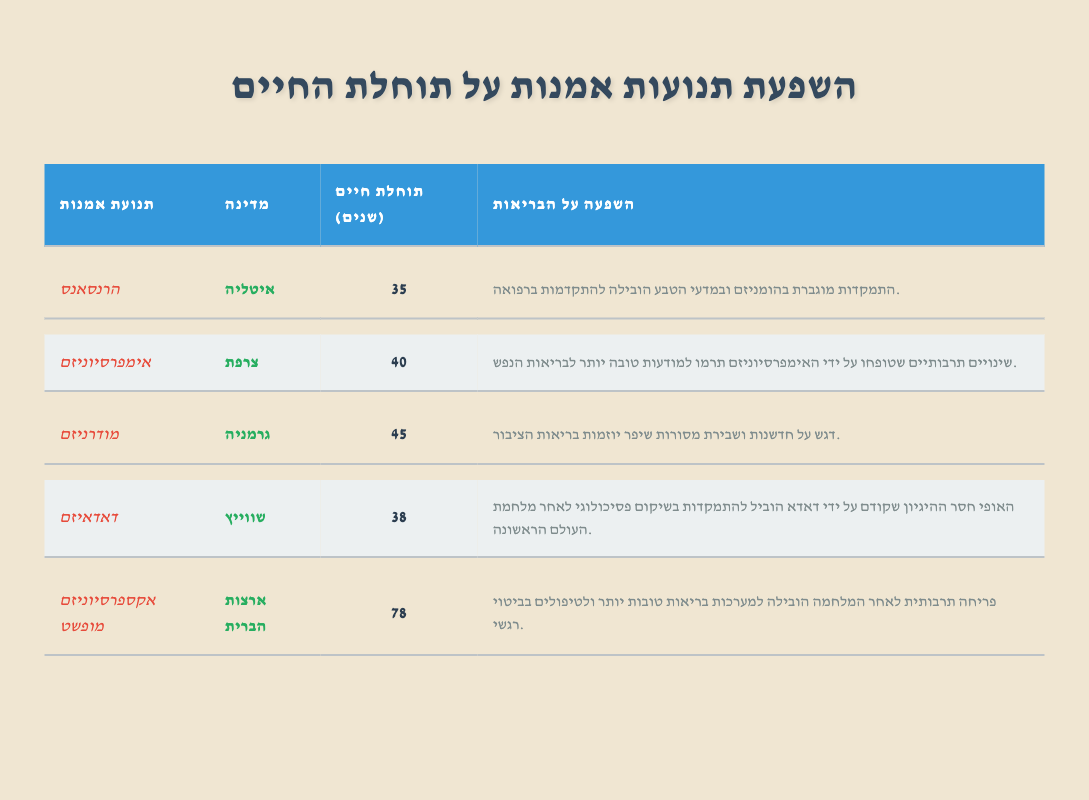What is the life expectancy in Italy? The life expectancy data for Italy, under the Renaissance art movement, is clearly stated in the table as 35 years.
Answer: 35 What country had the highest life expectancy among those listed? The country with the highest life expectancy is the United States, where the life expectancy is 78 years according to the Abstract Expressionism row.
Answer: United States What is the average life expectancy of the countries listed? To find the average life expectancy, we sum the life expectancies: 35 + 40 + 45 + 38 + 78 = 236. Then, we divide by the total number of countries listed, which is 5. Thus, the average is 236/5 = 47.2.
Answer: 47.2 Did Impressionism contribute to better mental health awareness? Yes, the influence of Impressionism on health is noted in the table, indicating it contributed to better mental health awareness.
Answer: Yes Which art movement had a potential influence on psychological rehabilitation after WWI? According to the table, Dadaism is the art movement that promoted a focus on psychological rehabilitation following WWI.
Answer: Dadaism How does the life expectancy of Abstract Expressionism compare to that of Dadaism? The life expectancy for Abstract Expressionism in the United States is 78 years, while for Dadaism in Switzerland, it's 38 years. The difference is calculated as 78 - 38 = 40 years. Thus, Abstract Expressionism has a greater life expectancy by 40 years.
Answer: 40 years Is the influence of Modernism related to advancements in public health initiatives? Yes, the table indicates that Modernism's emphasis on innovation and breaking traditions enhanced public health initiatives.
Answer: Yes What was the life expectancy for the art movement associated with Italy? The table shows that the life expectancy for the Renaissance art movement associated with Italy is 35 years.
Answer: 35 What is the difference in life expectancy between countries influenced by Renaissance and Abstract Expressionism? The life expectancy for Renaissance (Italy) is 35 years, and for Abstract Expressionism (United States) is 78 years. The difference is calculated as 78 - 35 = 43 years.
Answer: 43 years 